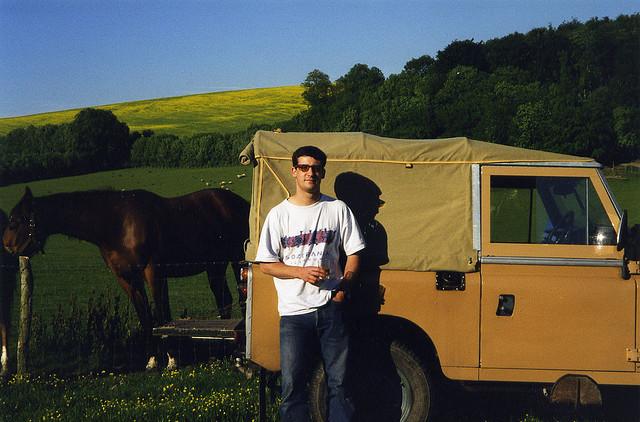What type of plant did the fence post used to be part of?
Quick response, please. Tree. Where was the photo taken?
Quick response, please. Outside. What animal is shown?
Answer briefly. Horse. Is this man trying to catch the animal?
Be succinct. No. What is the man standing in front of?
Short answer required. Jeep. 